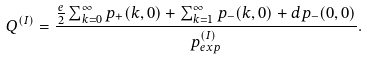Convert formula to latex. <formula><loc_0><loc_0><loc_500><loc_500>Q ^ { ( I ) } = \frac { \frac { e } { 2 } \sum _ { k = 0 } ^ { \infty } p _ { + } ( k , 0 ) + \sum _ { k = 1 } ^ { \infty } p _ { - } ( k , 0 ) + d p _ { - } ( 0 , 0 ) } { p _ { e x p } ^ { ( I ) } } .</formula> 